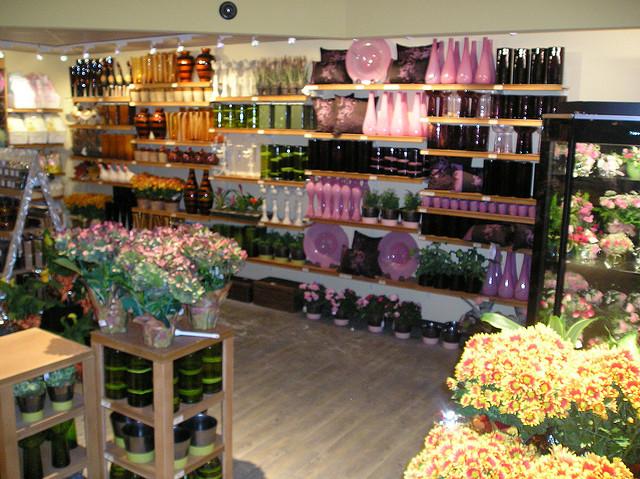What does this store specialize in?
Write a very short answer. Flowers. What does this vendor sell?
Concise answer only. Flowers. What color are the closest flowers in the photo?
Answer briefly. Yellow. Is this a retail setting?
Answer briefly. Yes. 